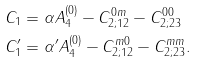Convert formula to latex. <formula><loc_0><loc_0><loc_500><loc_500>C _ { 1 } & = \alpha A _ { 4 } ^ { ( 0 ) } - C _ { 2 ; 1 2 } ^ { 0 m } - C _ { 2 ; 2 3 } ^ { 0 0 } \\ C _ { 1 } ^ { \prime } & = \alpha ^ { \prime } A _ { 4 } ^ { ( 0 ) } - C _ { 2 ; 1 2 } ^ { m 0 } - C _ { 2 ; 2 3 } ^ { m m } .</formula> 